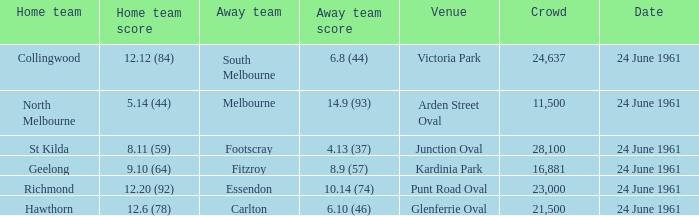12.6 (78) was scored by which home team? Hawthorn. 